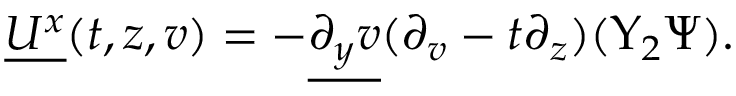<formula> <loc_0><loc_0><loc_500><loc_500>\begin{array} { r } { \underline { { U ^ { x } } } ( t , z , v ) = - \underline { { \partial _ { y } v } } ( \partial _ { v } - t \partial _ { z } ) ( \Upsilon _ { 2 } \Psi ) . } \end{array}</formula> 